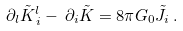Convert formula to latex. <formula><loc_0><loc_0><loc_500><loc_500>\partial _ { l } \tilde { K } _ { \, i } ^ { l } - \, \partial _ { i } \tilde { K } = 8 \pi G _ { 0 } \tilde { J } _ { i } \, .</formula> 